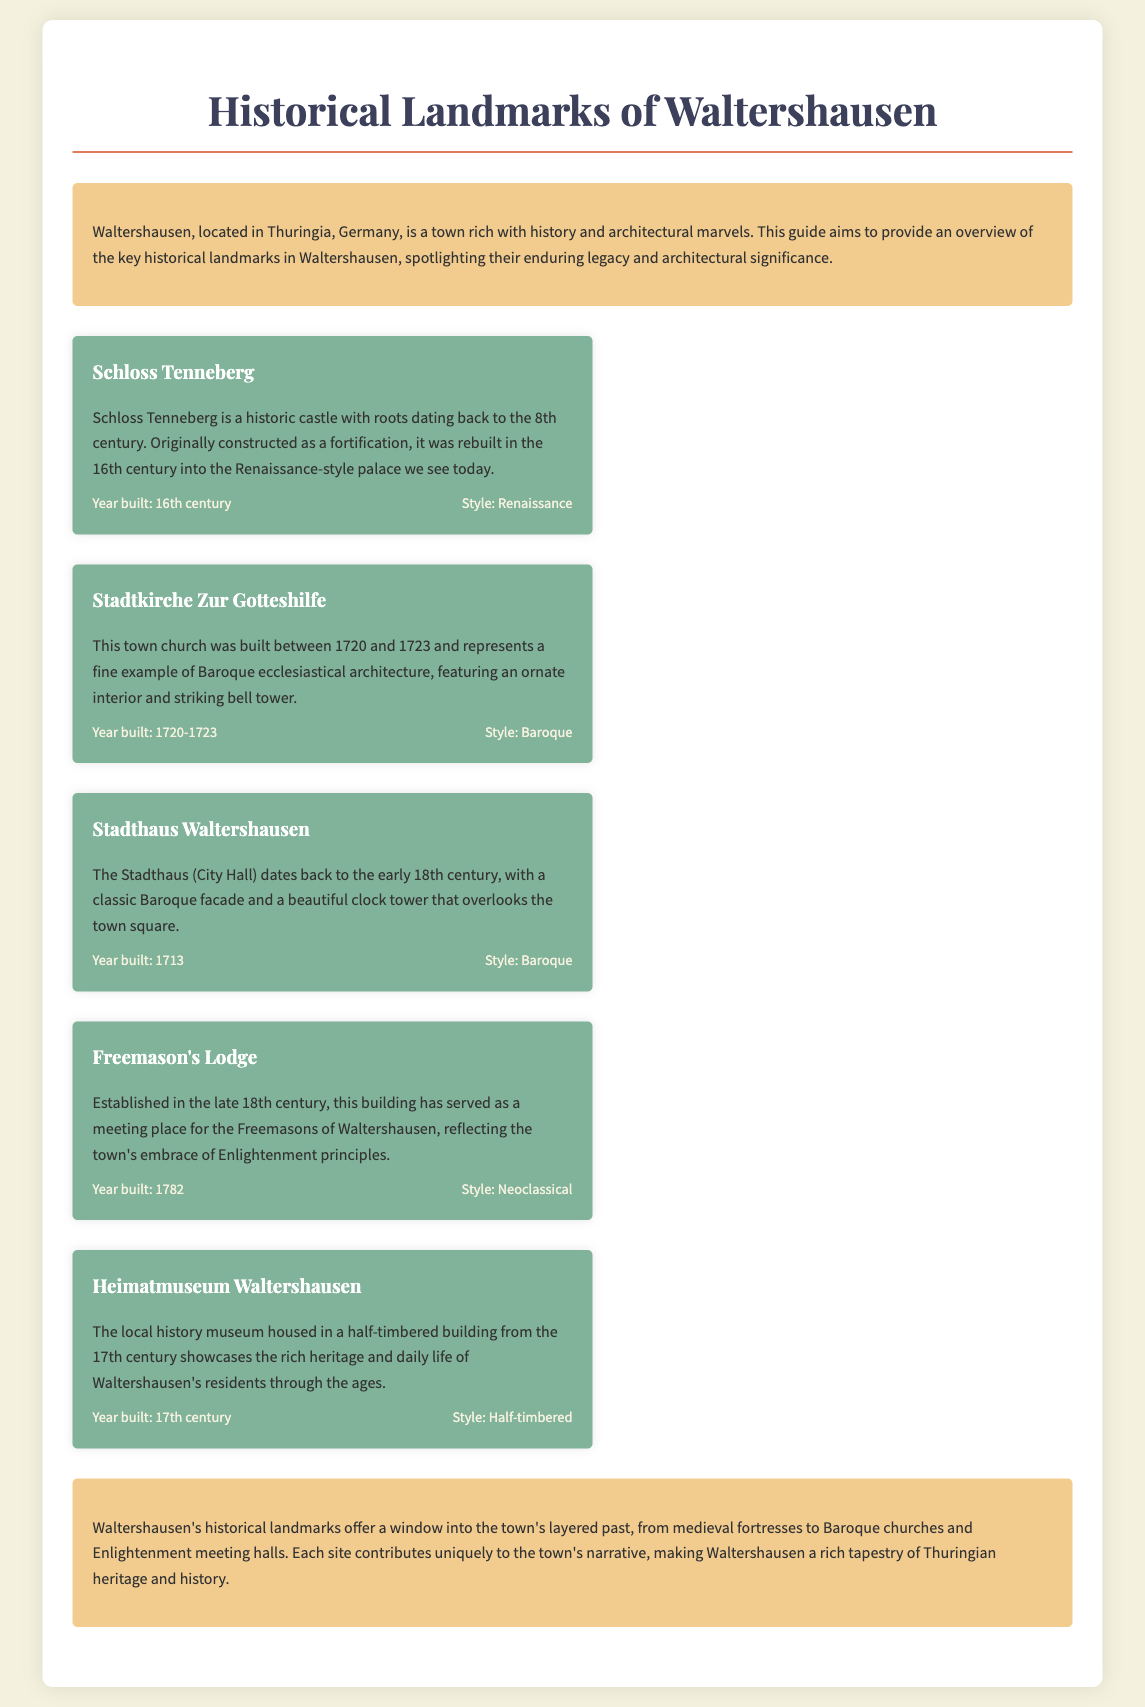What is the title of the guide? The title of the guide as presented in the document is the first heading, which introduces the subject matter.
Answer: Historical Landmarks of Waltershausen What architectural style is Schloss Tenneberg? The information about Schloss Tenneberg's architectural style is provided in its details section.
Answer: Renaissance What year was the Stadtkirche Zur Gotteshilfe built? The year of construction for Stadtkirche Zur Gotteshilfe is explicitly stated in the document.
Answer: 1720-1723 What type of building is the Heimatmuseum Waltershausen? The document classifies Heimatmuseum Waltershausen according to its architectural characteristics.
Answer: Half-timbered Which landmark was established in 1782? The document provides the founding year of significant landmarks, indicating which one was established in that year.
Answer: Freemason's Lodge What period does the Stadthaus Waltershausen belong to? The document mentions the construction date of the Stadthaus, which indicates its historical period.
Answer: Early 18th century How many landmarks are listed in the document? The total number of landmarks described in the guide can be counted from the respective sections within the document.
Answer: Five What is the color of the background in the introduction section? The background color of the introduction section is explicitly specified in the document's styling.
Answer: Light yellow What purpose does this guide serve? The introduction clearly states the aim of the guide regarding the town's historical landmarks.
Answer: Overview 